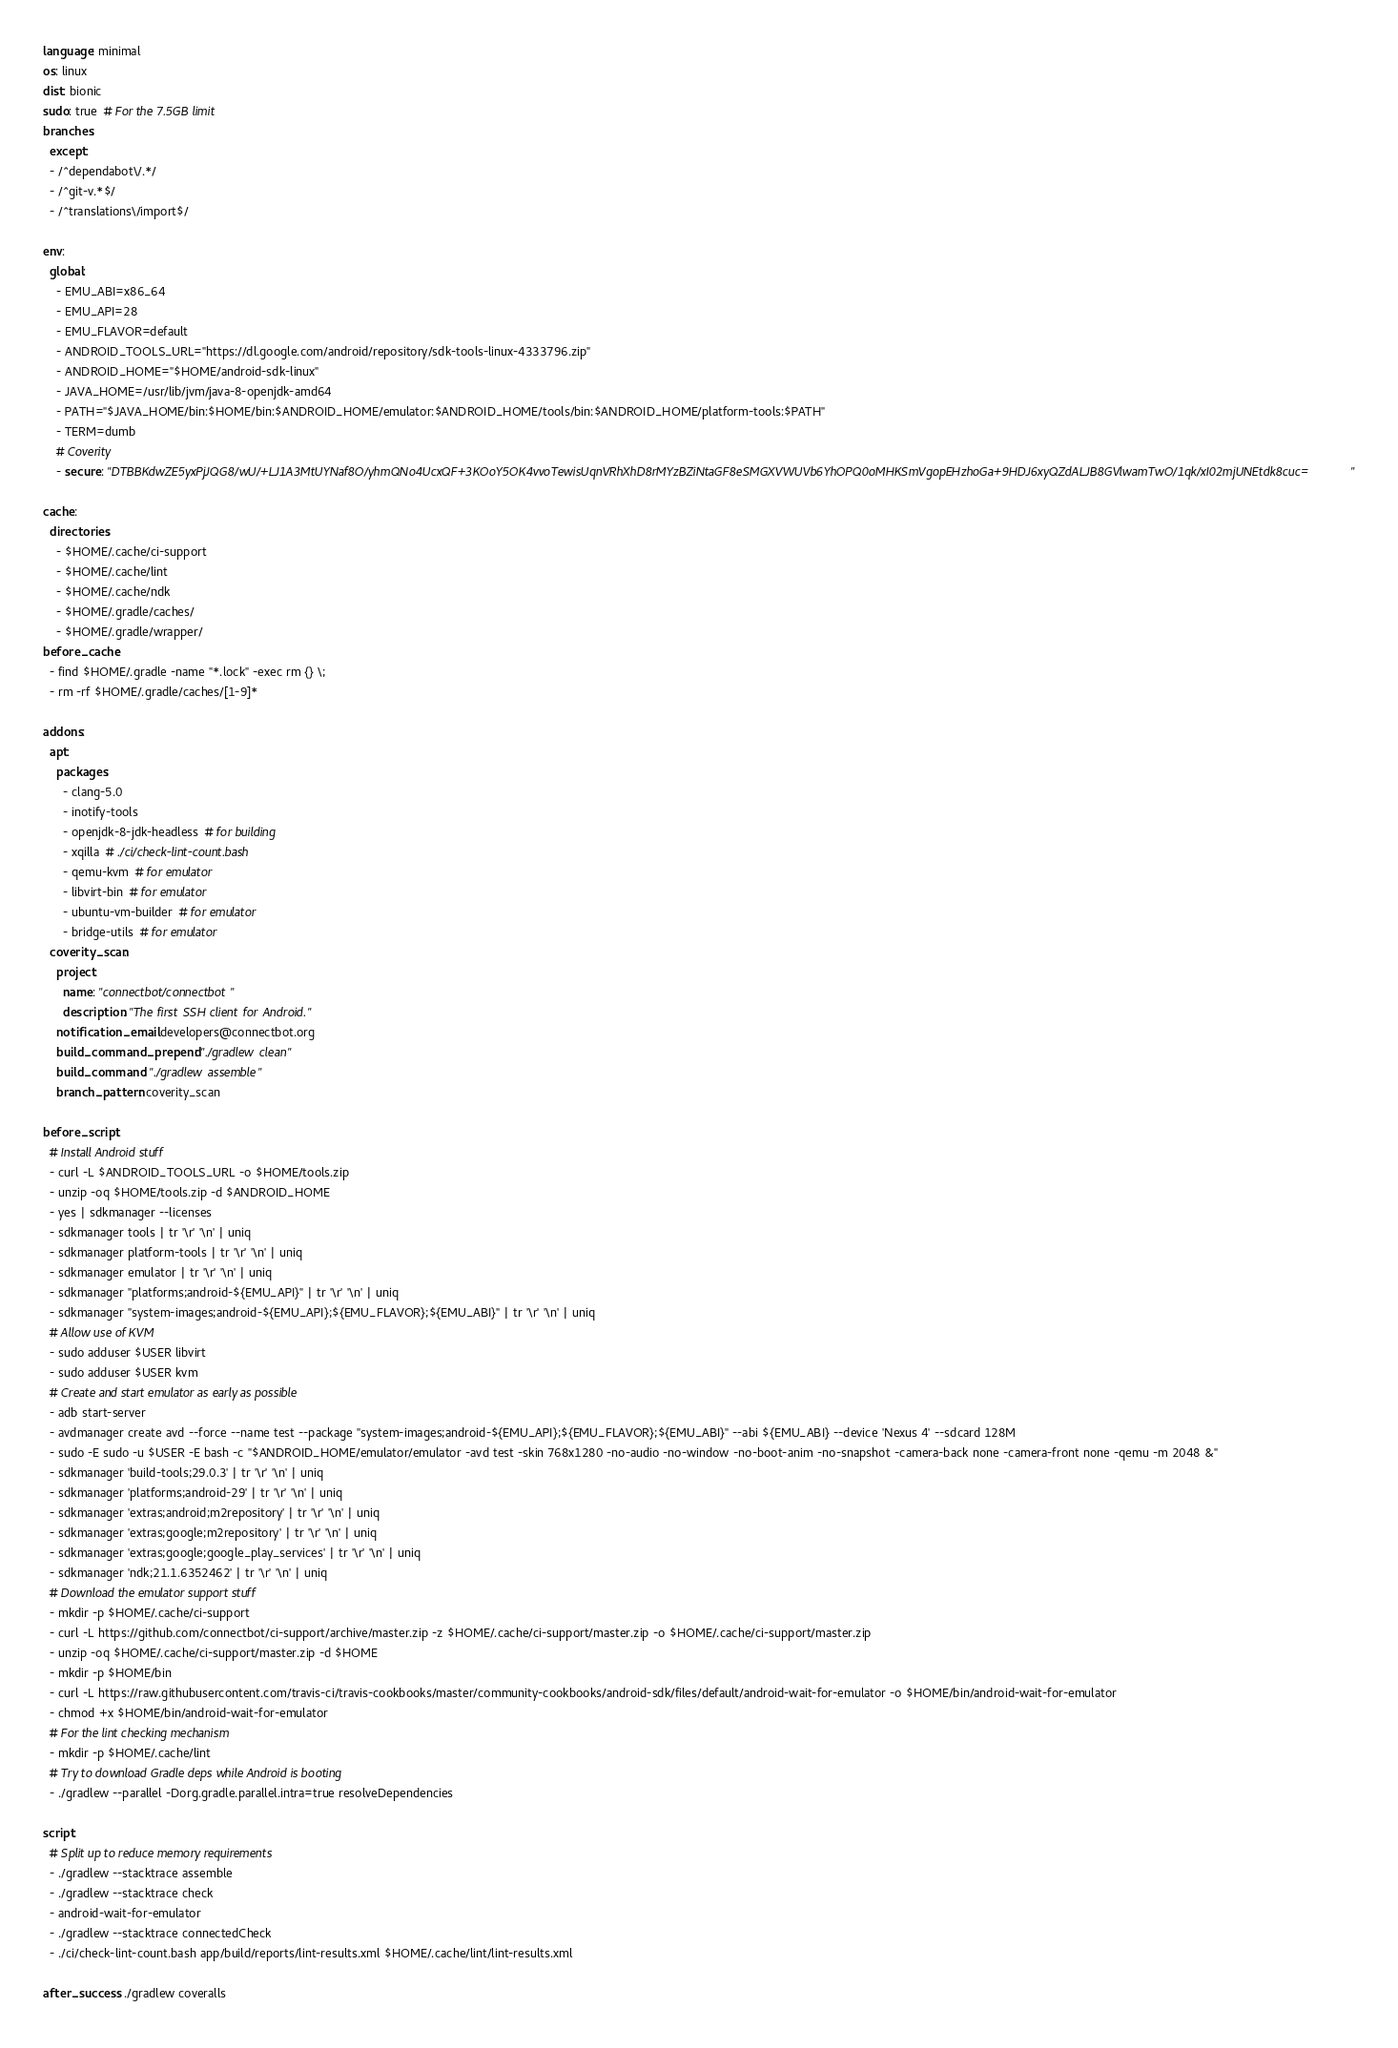<code> <loc_0><loc_0><loc_500><loc_500><_YAML_>language: minimal
os: linux
dist: bionic
sudo: true  # For the 7.5GB limit
branches:
  except:
  - /^dependabot\/.*/
  - /^git-v.*$/
  - /^translations\/import$/

env:
  global:
    - EMU_ABI=x86_64
    - EMU_API=28
    - EMU_FLAVOR=default
    - ANDROID_TOOLS_URL="https://dl.google.com/android/repository/sdk-tools-linux-4333796.zip"
    - ANDROID_HOME="$HOME/android-sdk-linux"
    - JAVA_HOME=/usr/lib/jvm/java-8-openjdk-amd64
    - PATH="$JAVA_HOME/bin:$HOME/bin:$ANDROID_HOME/emulator:$ANDROID_HOME/tools/bin:$ANDROID_HOME/platform-tools:$PATH"
    - TERM=dumb
    # Coverity
    - secure: "DTBBKdwZE5yxPjJQG8/wU/+LJ1A3MtUYNaf8O/yhmQNo4UcxQF+3KOoY5OK4vvoTewisUqnVRhXhD8rMYzBZiNtaGF8eSMGXVWUVb6YhOPQ0oMHKSmVgopEHzhoGa+9HDJ6xyQZdALJB8GVlwamTwO/1qk/xI02mjUNEtdk8cuc="

cache:
  directories:
    - $HOME/.cache/ci-support
    - $HOME/.cache/lint
    - $HOME/.cache/ndk
    - $HOME/.gradle/caches/
    - $HOME/.gradle/wrapper/
before_cache:
  - find $HOME/.gradle -name "*.lock" -exec rm {} \;
  - rm -rf $HOME/.gradle/caches/[1-9]*

addons:
  apt:
    packages:
      - clang-5.0
      - inotify-tools
      - openjdk-8-jdk-headless  # for building
      - xqilla  # ./ci/check-lint-count.bash
      - qemu-kvm  # for emulator
      - libvirt-bin  # for emulator
      - ubuntu-vm-builder  # for emulator
      - bridge-utils  # for emulator
  coverity_scan:
    project:
      name: "connectbot/connectbot"
      description: "The first SSH client for Android."
    notification_email: developers@connectbot.org
    build_command_prepend: "./gradlew clean"
    build_command: "./gradlew assemble"
    branch_pattern: coverity_scan

before_script:
  # Install Android stuff
  - curl -L $ANDROID_TOOLS_URL -o $HOME/tools.zip
  - unzip -oq $HOME/tools.zip -d $ANDROID_HOME
  - yes | sdkmanager --licenses
  - sdkmanager tools | tr '\r' '\n' | uniq
  - sdkmanager platform-tools | tr '\r' '\n' | uniq
  - sdkmanager emulator | tr '\r' '\n' | uniq
  - sdkmanager "platforms;android-${EMU_API}" | tr '\r' '\n' | uniq
  - sdkmanager "system-images;android-${EMU_API};${EMU_FLAVOR};${EMU_ABI}" | tr '\r' '\n' | uniq
  # Allow use of KVM
  - sudo adduser $USER libvirt
  - sudo adduser $USER kvm
  # Create and start emulator as early as possible
  - adb start-server
  - avdmanager create avd --force --name test --package "system-images;android-${EMU_API};${EMU_FLAVOR};${EMU_ABI}" --abi ${EMU_ABI} --device 'Nexus 4' --sdcard 128M
  - sudo -E sudo -u $USER -E bash -c "$ANDROID_HOME/emulator/emulator -avd test -skin 768x1280 -no-audio -no-window -no-boot-anim -no-snapshot -camera-back none -camera-front none -qemu -m 2048 &"
  - sdkmanager 'build-tools;29.0.3' | tr '\r' '\n' | uniq
  - sdkmanager 'platforms;android-29' | tr '\r' '\n' | uniq
  - sdkmanager 'extras;android;m2repository' | tr '\r' '\n' | uniq
  - sdkmanager 'extras;google;m2repository' | tr '\r' '\n' | uniq
  - sdkmanager 'extras;google;google_play_services' | tr '\r' '\n' | uniq
  - sdkmanager 'ndk;21.1.6352462' | tr '\r' '\n' | uniq
  # Download the emulator support stuff
  - mkdir -p $HOME/.cache/ci-support
  - curl -L https://github.com/connectbot/ci-support/archive/master.zip -z $HOME/.cache/ci-support/master.zip -o $HOME/.cache/ci-support/master.zip
  - unzip -oq $HOME/.cache/ci-support/master.zip -d $HOME
  - mkdir -p $HOME/bin
  - curl -L https://raw.githubusercontent.com/travis-ci/travis-cookbooks/master/community-cookbooks/android-sdk/files/default/android-wait-for-emulator -o $HOME/bin/android-wait-for-emulator
  - chmod +x $HOME/bin/android-wait-for-emulator
  # For the lint checking mechanism
  - mkdir -p $HOME/.cache/lint
  # Try to download Gradle deps while Android is booting
  - ./gradlew --parallel -Dorg.gradle.parallel.intra=true resolveDependencies

script:
  # Split up to reduce memory requirements
  - ./gradlew --stacktrace assemble
  - ./gradlew --stacktrace check
  - android-wait-for-emulator
  - ./gradlew --stacktrace connectedCheck
  - ./ci/check-lint-count.bash app/build/reports/lint-results.xml $HOME/.cache/lint/lint-results.xml

after_success: ./gradlew coveralls
</code> 